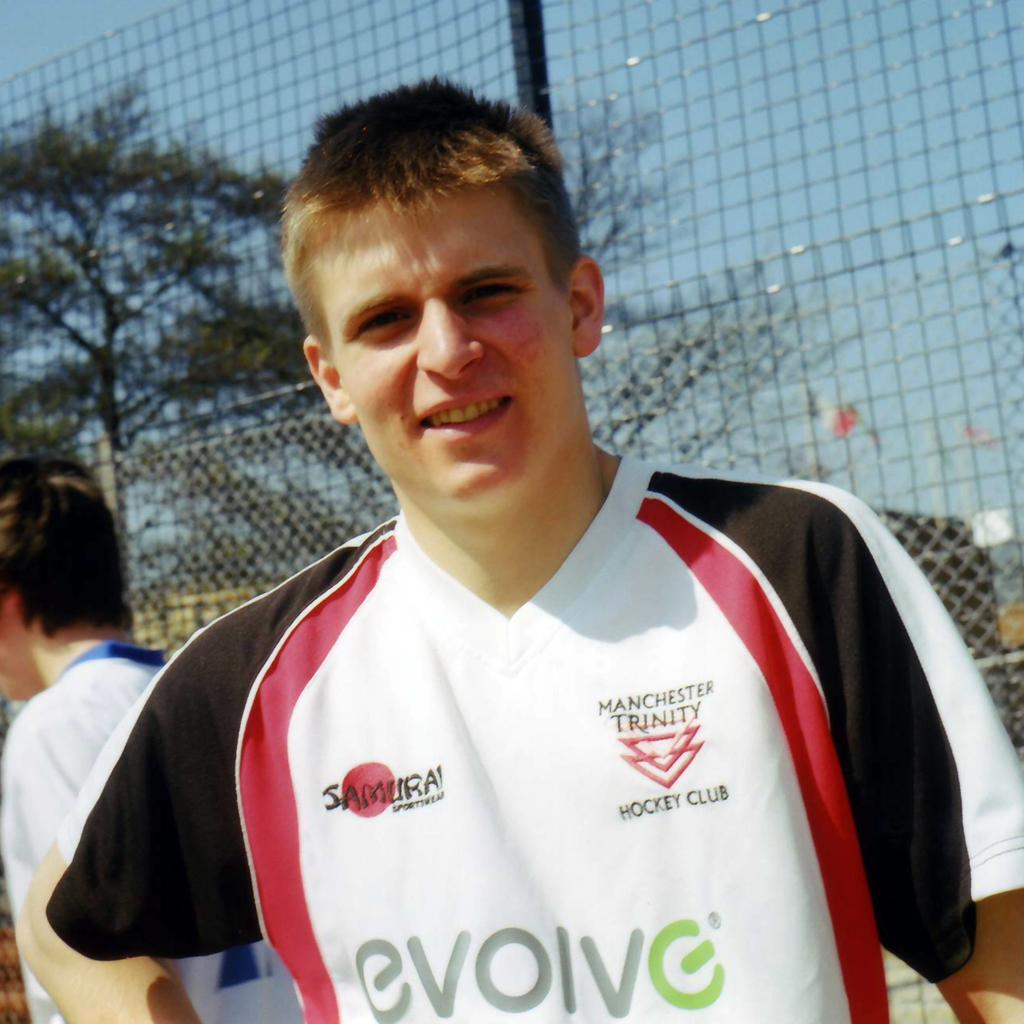<image>
Relay a brief, clear account of the picture shown. A picture of a hockey player from The Manchester Trinity Hockey Club. 